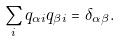<formula> <loc_0><loc_0><loc_500><loc_500>\sum _ { i } q _ { \alpha i } q _ { \beta i } = \delta _ { \alpha \beta } .</formula> 